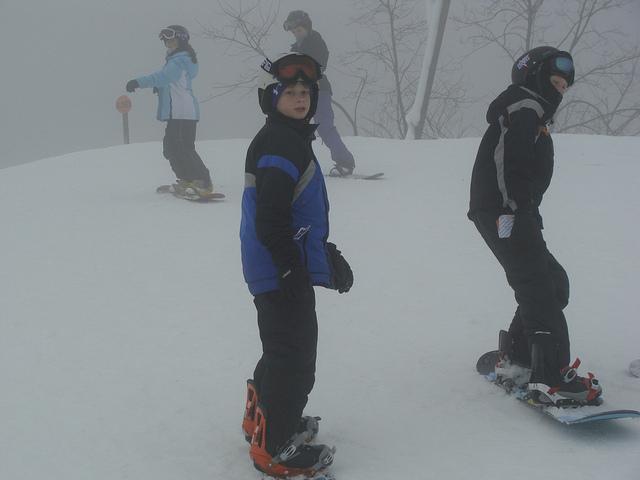How many people are in the image?
Give a very brief answer. 4. How many people are visible?
Give a very brief answer. 4. 